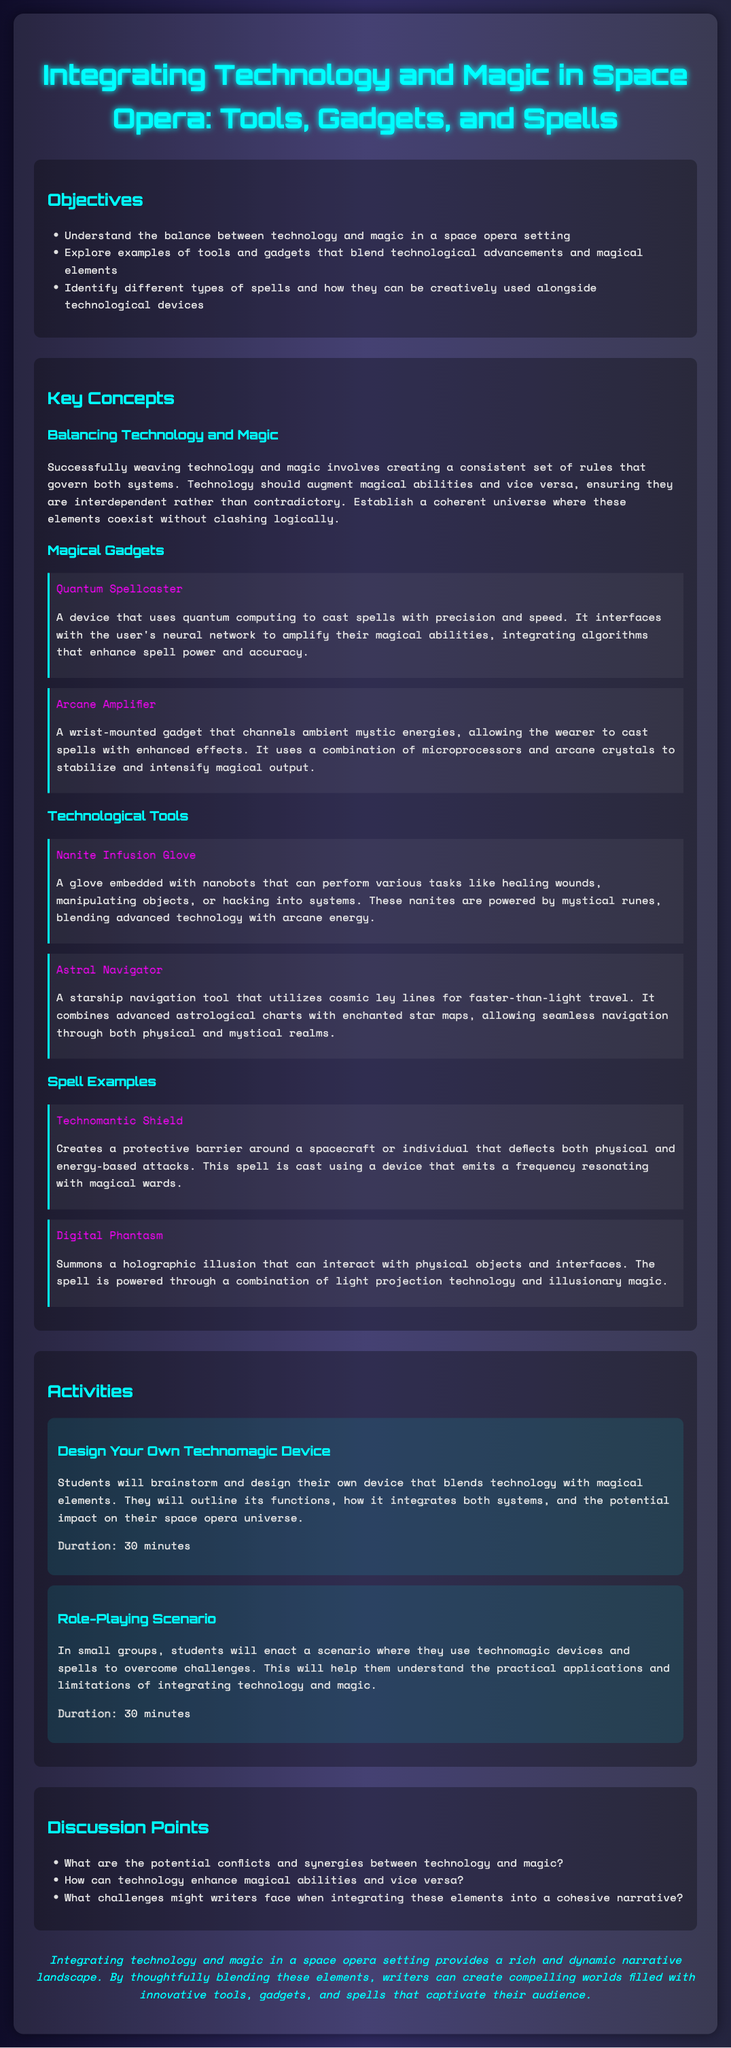What is the title of the lesson plan? The title is located at the top of the document, emphasizing the main topic discussed in the lesson plan.
Answer: Integrating Technology and Magic in Space Opera: Tools, Gadgets, and Spells What is one of the objectives listed? The objectives are presented in a bulleted list, highlighting key goals for the lesson.
Answer: Understand the balance between technology and magic in a space opera setting What device allows for spells to be cast with precision? The document provides examples of gadgets and explains their functionalities.
Answer: Quantum Spellcaster What does the Astral Navigator combine? The explanation of the Astral Navigator outlines what components it integrates for navigation purposes.
Answer: Advanced astrological charts and enchanted star maps How long is the "Design Your Own Technomagic Device" activity? The duration is mentioned alongside the activity description, indicating the time allotted for it.
Answer: 30 minutes What is one potential discussion point? The discussion points are listed to provoke thought and conversation regarding the lesson themes.
Answer: What are the potential conflicts and synergies between technology and magic? What does the Technomantic Shield create? The description of the spell explains its protective capabilities and uses in the narrative context.
Answer: A protective barrier Which gadget channels ambient mystic energies? The document lists gadgets and includes details about their specific functionalities related to magic.
Answer: Arcane Amplifier What does the Digital Phantasm summon? The function of the Digital Phantasm spell is described to highlight its interactive abilities.
Answer: A holographic illusion 